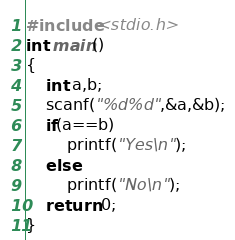<code> <loc_0><loc_0><loc_500><loc_500><_C_>#include<stdio.h>
int main()
{
    int a,b;
    scanf("%d%d",&a,&b);
    if(a==b)
        printf("Yes\n");
    else
        printf("No\n");
    return 0;
}
</code> 